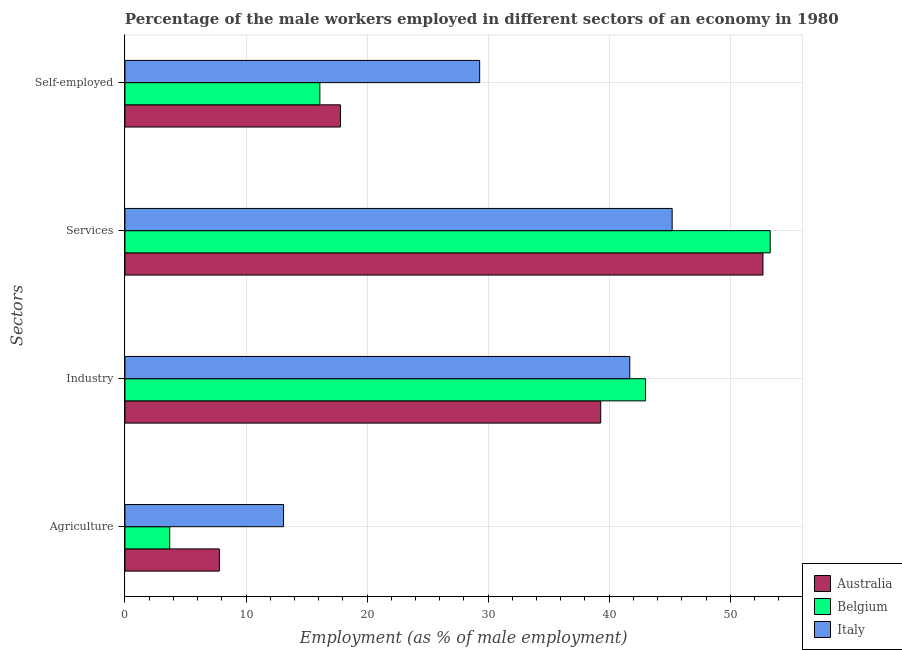How many groups of bars are there?
Provide a short and direct response. 4. Are the number of bars per tick equal to the number of legend labels?
Ensure brevity in your answer.  Yes. Are the number of bars on each tick of the Y-axis equal?
Your response must be concise. Yes. What is the label of the 4th group of bars from the top?
Your response must be concise. Agriculture. What is the percentage of male workers in services in Italy?
Your answer should be compact. 45.2. Across all countries, what is the maximum percentage of self employed male workers?
Make the answer very short. 29.3. Across all countries, what is the minimum percentage of male workers in services?
Offer a terse response. 45.2. What is the total percentage of male workers in agriculture in the graph?
Give a very brief answer. 24.6. What is the difference between the percentage of male workers in agriculture in Australia and that in Italy?
Ensure brevity in your answer.  -5.3. What is the difference between the percentage of male workers in services in Italy and the percentage of male workers in agriculture in Australia?
Your answer should be compact. 37.4. What is the average percentage of male workers in agriculture per country?
Make the answer very short. 8.2. What is the difference between the percentage of male workers in industry and percentage of male workers in agriculture in Australia?
Give a very brief answer. 31.5. In how many countries, is the percentage of male workers in services greater than 10 %?
Make the answer very short. 3. What is the ratio of the percentage of male workers in agriculture in Australia to that in Belgium?
Provide a succinct answer. 2.11. Is the percentage of male workers in industry in Australia less than that in Belgium?
Make the answer very short. Yes. What is the difference between the highest and the second highest percentage of male workers in industry?
Your answer should be very brief. 1.3. What is the difference between the highest and the lowest percentage of male workers in industry?
Keep it short and to the point. 3.7. Is the sum of the percentage of male workers in agriculture in Italy and Australia greater than the maximum percentage of male workers in industry across all countries?
Your response must be concise. No. What does the 1st bar from the top in Self-employed represents?
Provide a short and direct response. Italy. Is it the case that in every country, the sum of the percentage of male workers in agriculture and percentage of male workers in industry is greater than the percentage of male workers in services?
Offer a terse response. No. How many bars are there?
Give a very brief answer. 12. How many countries are there in the graph?
Offer a very short reply. 3. What is the difference between two consecutive major ticks on the X-axis?
Make the answer very short. 10. Are the values on the major ticks of X-axis written in scientific E-notation?
Provide a short and direct response. No. Where does the legend appear in the graph?
Offer a terse response. Bottom right. How many legend labels are there?
Offer a terse response. 3. How are the legend labels stacked?
Ensure brevity in your answer.  Vertical. What is the title of the graph?
Your answer should be compact. Percentage of the male workers employed in different sectors of an economy in 1980. What is the label or title of the X-axis?
Give a very brief answer. Employment (as % of male employment). What is the label or title of the Y-axis?
Make the answer very short. Sectors. What is the Employment (as % of male employment) of Australia in Agriculture?
Provide a succinct answer. 7.8. What is the Employment (as % of male employment) of Belgium in Agriculture?
Provide a short and direct response. 3.7. What is the Employment (as % of male employment) in Italy in Agriculture?
Give a very brief answer. 13.1. What is the Employment (as % of male employment) in Australia in Industry?
Your response must be concise. 39.3. What is the Employment (as % of male employment) in Italy in Industry?
Give a very brief answer. 41.7. What is the Employment (as % of male employment) in Australia in Services?
Ensure brevity in your answer.  52.7. What is the Employment (as % of male employment) in Belgium in Services?
Your response must be concise. 53.3. What is the Employment (as % of male employment) in Italy in Services?
Your response must be concise. 45.2. What is the Employment (as % of male employment) of Australia in Self-employed?
Provide a succinct answer. 17.8. What is the Employment (as % of male employment) of Belgium in Self-employed?
Make the answer very short. 16.1. What is the Employment (as % of male employment) in Italy in Self-employed?
Offer a terse response. 29.3. Across all Sectors, what is the maximum Employment (as % of male employment) in Australia?
Your answer should be compact. 52.7. Across all Sectors, what is the maximum Employment (as % of male employment) of Belgium?
Your answer should be very brief. 53.3. Across all Sectors, what is the maximum Employment (as % of male employment) of Italy?
Your response must be concise. 45.2. Across all Sectors, what is the minimum Employment (as % of male employment) in Australia?
Make the answer very short. 7.8. Across all Sectors, what is the minimum Employment (as % of male employment) of Belgium?
Provide a short and direct response. 3.7. Across all Sectors, what is the minimum Employment (as % of male employment) in Italy?
Ensure brevity in your answer.  13.1. What is the total Employment (as % of male employment) in Australia in the graph?
Provide a succinct answer. 117.6. What is the total Employment (as % of male employment) in Belgium in the graph?
Keep it short and to the point. 116.1. What is the total Employment (as % of male employment) of Italy in the graph?
Ensure brevity in your answer.  129.3. What is the difference between the Employment (as % of male employment) of Australia in Agriculture and that in Industry?
Your answer should be very brief. -31.5. What is the difference between the Employment (as % of male employment) of Belgium in Agriculture and that in Industry?
Your response must be concise. -39.3. What is the difference between the Employment (as % of male employment) in Italy in Agriculture and that in Industry?
Your answer should be very brief. -28.6. What is the difference between the Employment (as % of male employment) of Australia in Agriculture and that in Services?
Your answer should be very brief. -44.9. What is the difference between the Employment (as % of male employment) in Belgium in Agriculture and that in Services?
Your answer should be very brief. -49.6. What is the difference between the Employment (as % of male employment) in Italy in Agriculture and that in Services?
Ensure brevity in your answer.  -32.1. What is the difference between the Employment (as % of male employment) in Australia in Agriculture and that in Self-employed?
Offer a very short reply. -10. What is the difference between the Employment (as % of male employment) of Italy in Agriculture and that in Self-employed?
Keep it short and to the point. -16.2. What is the difference between the Employment (as % of male employment) of Australia in Industry and that in Services?
Give a very brief answer. -13.4. What is the difference between the Employment (as % of male employment) in Belgium in Industry and that in Self-employed?
Provide a succinct answer. 26.9. What is the difference between the Employment (as % of male employment) in Italy in Industry and that in Self-employed?
Your answer should be very brief. 12.4. What is the difference between the Employment (as % of male employment) in Australia in Services and that in Self-employed?
Keep it short and to the point. 34.9. What is the difference between the Employment (as % of male employment) in Belgium in Services and that in Self-employed?
Keep it short and to the point. 37.2. What is the difference between the Employment (as % of male employment) in Australia in Agriculture and the Employment (as % of male employment) in Belgium in Industry?
Ensure brevity in your answer.  -35.2. What is the difference between the Employment (as % of male employment) of Australia in Agriculture and the Employment (as % of male employment) of Italy in Industry?
Offer a terse response. -33.9. What is the difference between the Employment (as % of male employment) of Belgium in Agriculture and the Employment (as % of male employment) of Italy in Industry?
Keep it short and to the point. -38. What is the difference between the Employment (as % of male employment) of Australia in Agriculture and the Employment (as % of male employment) of Belgium in Services?
Provide a short and direct response. -45.5. What is the difference between the Employment (as % of male employment) of Australia in Agriculture and the Employment (as % of male employment) of Italy in Services?
Ensure brevity in your answer.  -37.4. What is the difference between the Employment (as % of male employment) in Belgium in Agriculture and the Employment (as % of male employment) in Italy in Services?
Your answer should be compact. -41.5. What is the difference between the Employment (as % of male employment) in Australia in Agriculture and the Employment (as % of male employment) in Italy in Self-employed?
Provide a short and direct response. -21.5. What is the difference between the Employment (as % of male employment) in Belgium in Agriculture and the Employment (as % of male employment) in Italy in Self-employed?
Offer a terse response. -25.6. What is the difference between the Employment (as % of male employment) of Australia in Industry and the Employment (as % of male employment) of Belgium in Self-employed?
Your response must be concise. 23.2. What is the difference between the Employment (as % of male employment) in Belgium in Industry and the Employment (as % of male employment) in Italy in Self-employed?
Your answer should be very brief. 13.7. What is the difference between the Employment (as % of male employment) of Australia in Services and the Employment (as % of male employment) of Belgium in Self-employed?
Your answer should be compact. 36.6. What is the difference between the Employment (as % of male employment) in Australia in Services and the Employment (as % of male employment) in Italy in Self-employed?
Give a very brief answer. 23.4. What is the average Employment (as % of male employment) in Australia per Sectors?
Give a very brief answer. 29.4. What is the average Employment (as % of male employment) of Belgium per Sectors?
Offer a very short reply. 29.02. What is the average Employment (as % of male employment) of Italy per Sectors?
Your answer should be compact. 32.33. What is the difference between the Employment (as % of male employment) in Australia and Employment (as % of male employment) in Belgium in Agriculture?
Provide a succinct answer. 4.1. What is the difference between the Employment (as % of male employment) of Australia and Employment (as % of male employment) of Belgium in Industry?
Offer a terse response. -3.7. What is the difference between the Employment (as % of male employment) in Australia and Employment (as % of male employment) in Italy in Industry?
Offer a very short reply. -2.4. What is the difference between the Employment (as % of male employment) in Belgium and Employment (as % of male employment) in Italy in Services?
Your response must be concise. 8.1. What is the difference between the Employment (as % of male employment) of Australia and Employment (as % of male employment) of Belgium in Self-employed?
Your response must be concise. 1.7. What is the difference between the Employment (as % of male employment) in Belgium and Employment (as % of male employment) in Italy in Self-employed?
Provide a succinct answer. -13.2. What is the ratio of the Employment (as % of male employment) in Australia in Agriculture to that in Industry?
Give a very brief answer. 0.2. What is the ratio of the Employment (as % of male employment) of Belgium in Agriculture to that in Industry?
Provide a succinct answer. 0.09. What is the ratio of the Employment (as % of male employment) of Italy in Agriculture to that in Industry?
Make the answer very short. 0.31. What is the ratio of the Employment (as % of male employment) in Australia in Agriculture to that in Services?
Ensure brevity in your answer.  0.15. What is the ratio of the Employment (as % of male employment) of Belgium in Agriculture to that in Services?
Offer a terse response. 0.07. What is the ratio of the Employment (as % of male employment) of Italy in Agriculture to that in Services?
Offer a terse response. 0.29. What is the ratio of the Employment (as % of male employment) in Australia in Agriculture to that in Self-employed?
Your answer should be compact. 0.44. What is the ratio of the Employment (as % of male employment) of Belgium in Agriculture to that in Self-employed?
Provide a short and direct response. 0.23. What is the ratio of the Employment (as % of male employment) of Italy in Agriculture to that in Self-employed?
Your answer should be compact. 0.45. What is the ratio of the Employment (as % of male employment) in Australia in Industry to that in Services?
Make the answer very short. 0.75. What is the ratio of the Employment (as % of male employment) of Belgium in Industry to that in Services?
Your answer should be compact. 0.81. What is the ratio of the Employment (as % of male employment) in Italy in Industry to that in Services?
Offer a terse response. 0.92. What is the ratio of the Employment (as % of male employment) in Australia in Industry to that in Self-employed?
Keep it short and to the point. 2.21. What is the ratio of the Employment (as % of male employment) in Belgium in Industry to that in Self-employed?
Keep it short and to the point. 2.67. What is the ratio of the Employment (as % of male employment) of Italy in Industry to that in Self-employed?
Make the answer very short. 1.42. What is the ratio of the Employment (as % of male employment) of Australia in Services to that in Self-employed?
Your answer should be very brief. 2.96. What is the ratio of the Employment (as % of male employment) of Belgium in Services to that in Self-employed?
Give a very brief answer. 3.31. What is the ratio of the Employment (as % of male employment) in Italy in Services to that in Self-employed?
Make the answer very short. 1.54. What is the difference between the highest and the second highest Employment (as % of male employment) in Belgium?
Provide a short and direct response. 10.3. What is the difference between the highest and the second highest Employment (as % of male employment) in Italy?
Ensure brevity in your answer.  3.5. What is the difference between the highest and the lowest Employment (as % of male employment) of Australia?
Offer a very short reply. 44.9. What is the difference between the highest and the lowest Employment (as % of male employment) in Belgium?
Your answer should be compact. 49.6. What is the difference between the highest and the lowest Employment (as % of male employment) in Italy?
Offer a terse response. 32.1. 